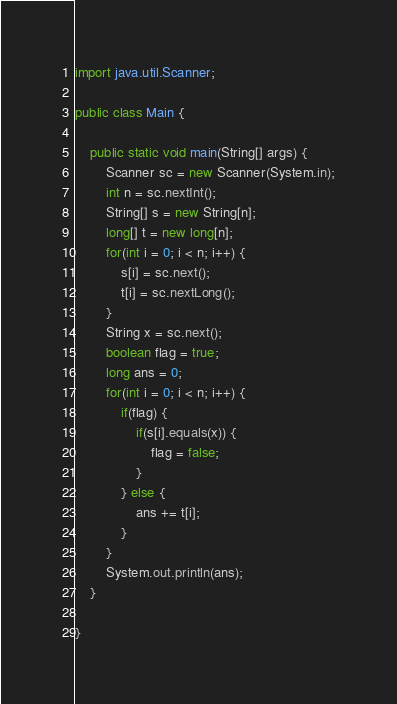<code> <loc_0><loc_0><loc_500><loc_500><_Java_>
import java.util.Scanner;

public class Main {

	public static void main(String[] args) {
		Scanner sc = new Scanner(System.in);
		int n = sc.nextInt();
		String[] s = new String[n];
		long[] t = new long[n];
		for(int i = 0; i < n; i++) {
			s[i] = sc.next();
			t[i] = sc.nextLong();
		}
		String x = sc.next();
		boolean flag = true;
		long ans = 0;
		for(int i = 0; i < n; i++) {
			if(flag) {
				if(s[i].equals(x)) {
					flag = false;
				}
			} else {
				ans += t[i];
			}
		}
		System.out.println(ans);
	}

}
</code> 